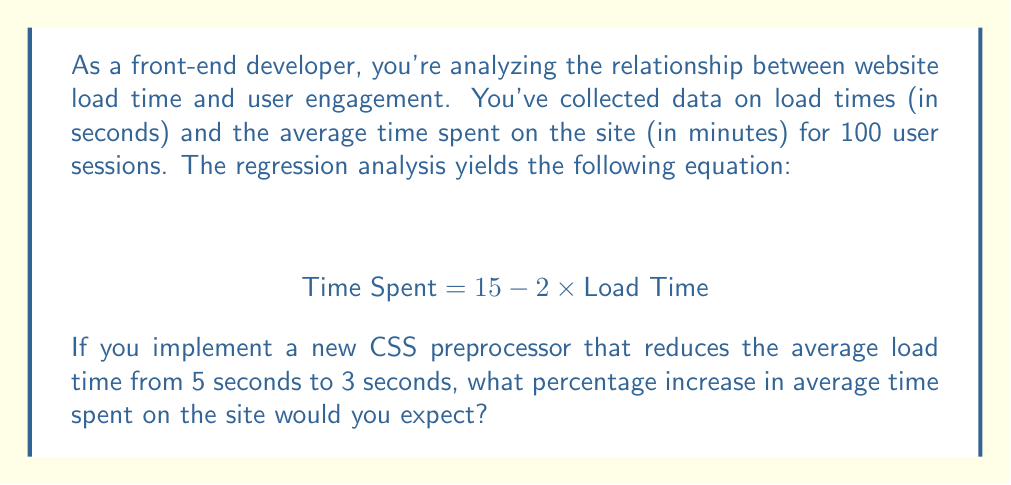Show me your answer to this math problem. Let's approach this step-by-step:

1) We're given the regression equation:
   $$ \text{Time Spent} = 15 - 2 \times \text{Load Time} $$

2) First, let's calculate the expected time spent with the current average load time of 5 seconds:
   $$ \text{Time Spent}_{\text{current}} = 15 - 2 \times 5 = 15 - 10 = 5 \text{ minutes} $$

3) Now, let's calculate the expected time spent with the new average load time of 3 seconds:
   $$ \text{Time Spent}_{\text{new}} = 15 - 2 \times 3 = 15 - 6 = 9 \text{ minutes} $$

4) To calculate the percentage increase, we use the formula:
   $$ \text{Percentage Increase} = \frac{\text{New Value} - \text{Original Value}}{\text{Original Value}} \times 100\% $$

5) Plugging in our values:
   $$ \text{Percentage Increase} = \frac{9 - 5}{5} \times 100\% = \frac{4}{5} \times 100\% = 80\% $$

Therefore, we would expect an 80% increase in the average time spent on the site.
Answer: 80% 